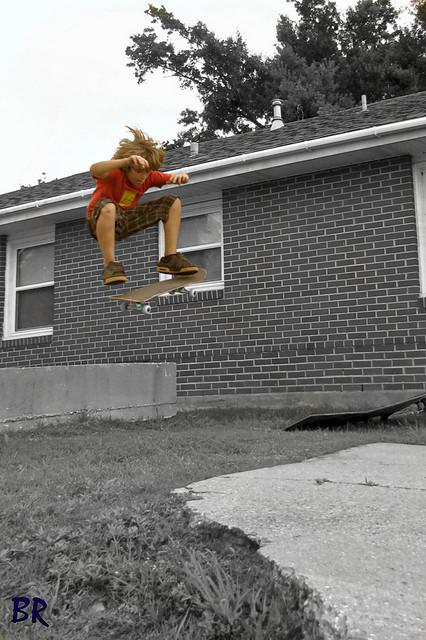What is the boy doing?
Write a very short answer. Skateboarding. What is under the boy's feet?
Short answer required. Skateboard. Is there a tree in this picture?
Keep it brief. Yes. 